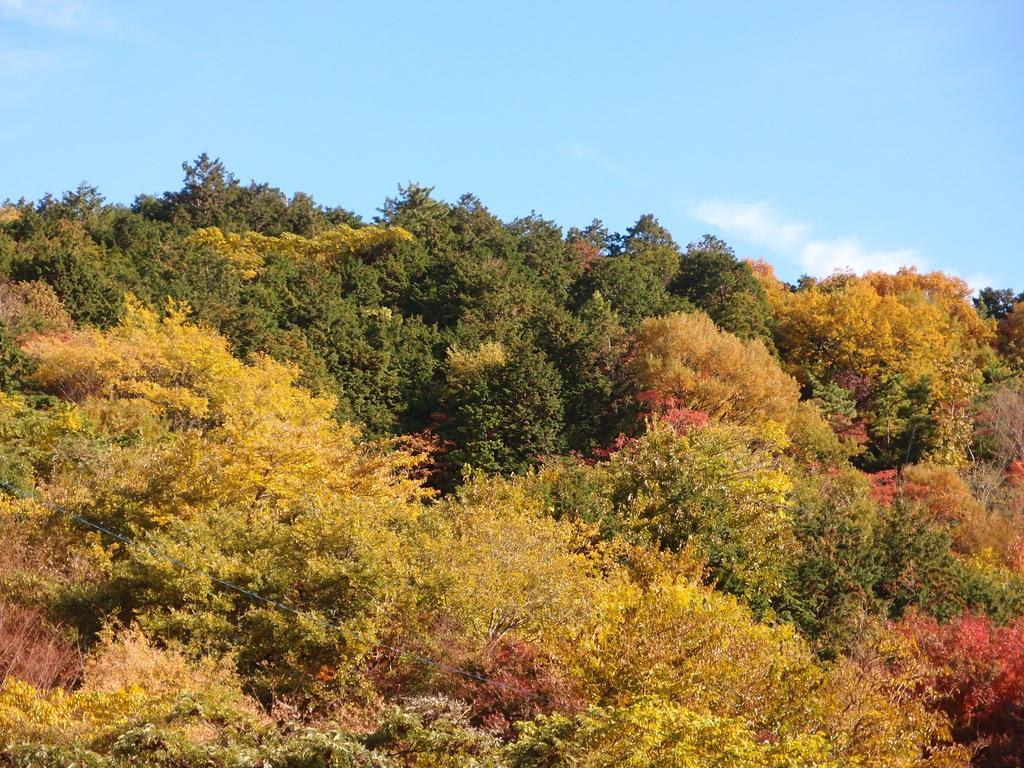What type of vegetation can be seen in the image? There are trees in the image. What can be seen in the sky in the image? There are clouds visible in the sky in the image. How many bikes are parked under the trees in the image? There are no bikes present in the image; it only features trees and clouds in the sky. 